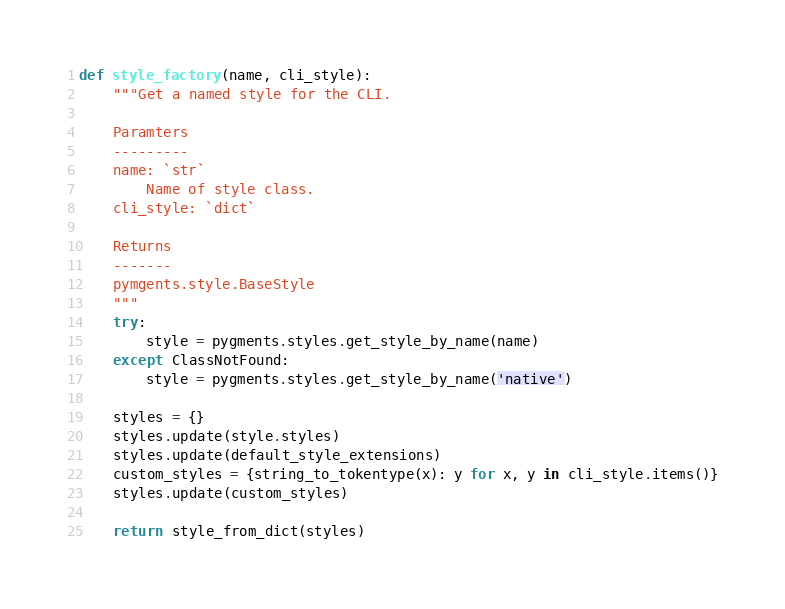Convert code to text. <code><loc_0><loc_0><loc_500><loc_500><_Python_>
def style_factory(name, cli_style):
    """Get a named style for the CLI.

    Paramters
    ---------
    name: `str`
        Name of style class.
    cli_style: `dict`
    
    Returns
    -------
    pymgents.style.BaseStyle
    """
    try:
        style = pygments.styles.get_style_by_name(name)
    except ClassNotFound:
        style = pygments.styles.get_style_by_name('native')

    styles = {}
    styles.update(style.styles)
    styles.update(default_style_extensions)
    custom_styles = {string_to_tokentype(x): y for x, y in cli_style.items()}
    styles.update(custom_styles)

    return style_from_dict(styles)

</code> 